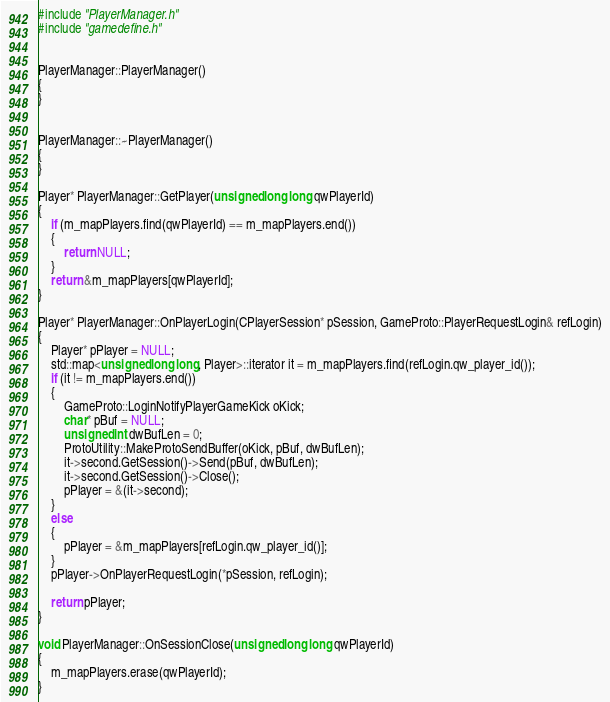<code> <loc_0><loc_0><loc_500><loc_500><_C++_>#include "PlayerManager.h"
#include "gamedefine.h"


PlayerManager::PlayerManager()
{
}


PlayerManager::~PlayerManager()
{
}

Player* PlayerManager::GetPlayer(unsigned long long qwPlayerId)
{
	if (m_mapPlayers.find(qwPlayerId) == m_mapPlayers.end())
	{
		return NULL;
	}
	return &m_mapPlayers[qwPlayerId];
}

Player* PlayerManager::OnPlayerLogin(CPlayerSession* pSession, GameProto::PlayerRequestLogin& refLogin)
{
	Player* pPlayer = NULL;
	std::map<unsigned long long, Player>::iterator it = m_mapPlayers.find(refLogin.qw_player_id());
	if (it != m_mapPlayers.end())
	{
		GameProto::LoginNotifyPlayerGameKick oKick;
		char* pBuf = NULL;
		unsigned int dwBufLen = 0;
		ProtoUtility::MakeProtoSendBuffer(oKick, pBuf, dwBufLen);
		it->second.GetSession()->Send(pBuf, dwBufLen);
		it->second.GetSession()->Close();
		pPlayer = &(it->second);
	}
	else
	{
		pPlayer = &m_mapPlayers[refLogin.qw_player_id()];
	}
	pPlayer->OnPlayerRequestLogin(*pSession, refLogin);

	return pPlayer;
}

void PlayerManager::OnSessionClose(unsigned long long qwPlayerId)
{
	m_mapPlayers.erase(qwPlayerId);
}
</code> 